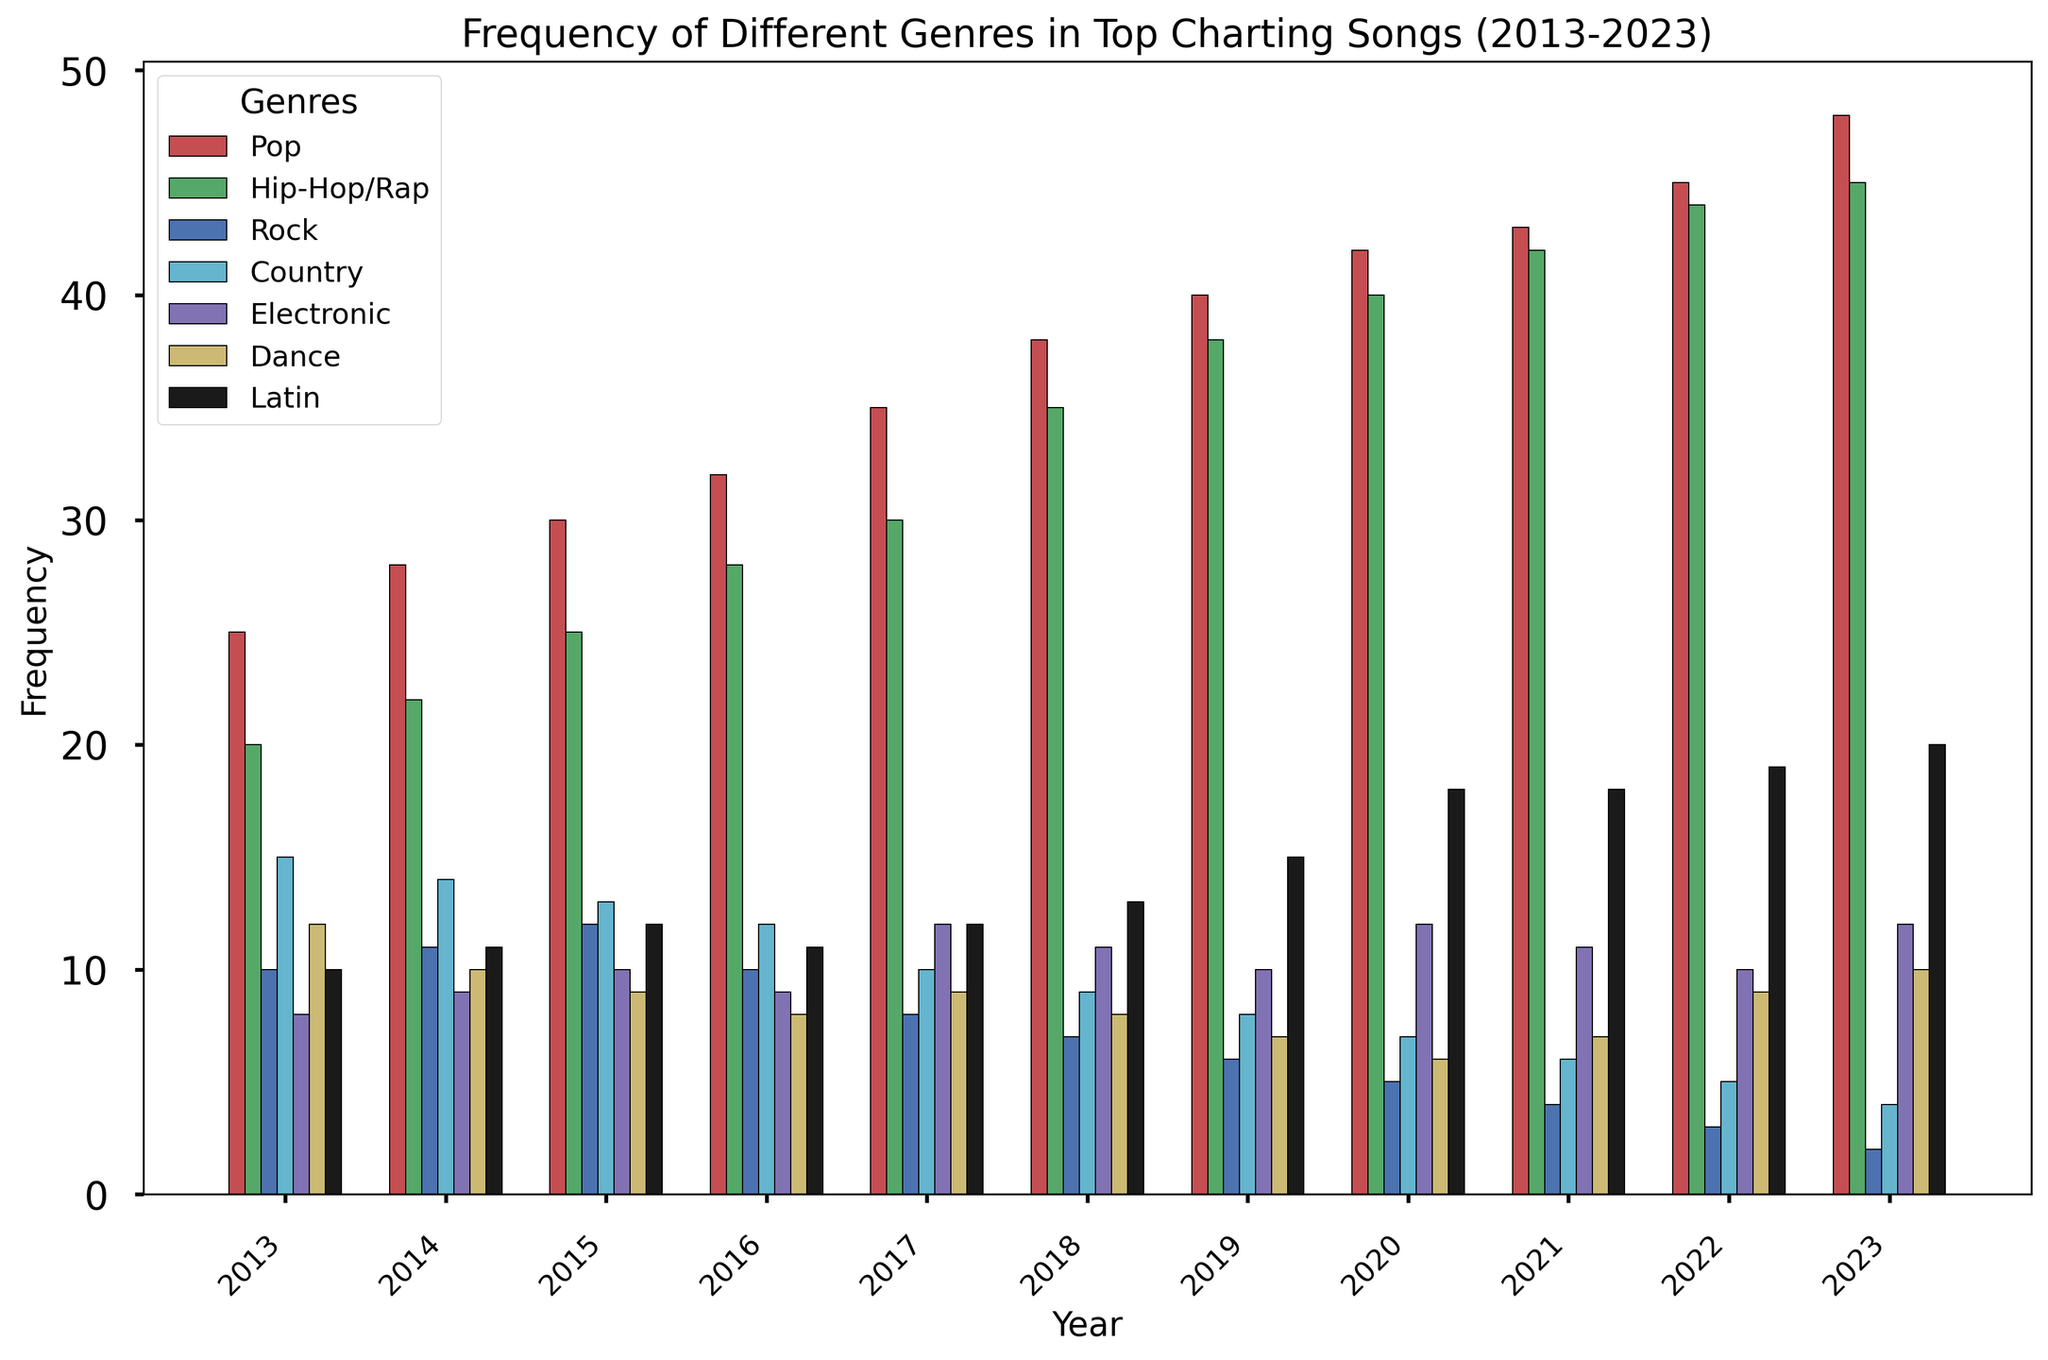What's the most frequently appearing genre in 2023? Pop has the tallest bar in 2023, indicating it is the most frequently appearing genre.
Answer: Pop Which genre has shown a consistent increase across all years? Pop and Hip-Hop/Rap both show a consistent increase from 2013 to 2023, but Pop increases in every single year without any drop.
Answer: Pop What's the sum of frequencies for Country and Dance genres in 2016? In 2016, the frequency for Country is 12, and for Dance, it is 8. Summing these gives 12 + 8 = 20.
Answer: 20 What was the trend for Rock genre from 2016 to 2023? From 2016 to 2023, the frequency of Rock songs consistently decreased, going from 10 down to 2.
Answer: Decreasing In which year did Latin music surpass Electronic music in frequency? Latin music surpassed Electronic music in 2019. In this year, Latin had a frequency of 15 while Electronic had 10.
Answer: 2019 Which genre had the smallest frequency in 2013? In 2013, the smallest frequency is for Electronic genre, with a count of 8.
Answer: Electronic Compare the frequency of Hip-Hop/Rap and Rock in 2020. In 2020, Hip-Hop/Rap has a frequency of 40, while Rock has a frequency of 5. Hip-Hop/Rap is significantly higher.
Answer: Hip-Hop/Rap Calculate the average frequency of Pop music from 2013 to 2023. The sum of frequencies for Pop from 2013 to 2023 is 25 + 28 + 30 + 32 + 35 + 38 + 40 + 42 + 43 + 45 + 48 = 406. There are 11 years, so the average is 406 / 11 ≈ 36.91.
Answer: 36.91 What visual attribute indicates that Pop music is the most dominant genre? The tallest bars across all years consistently belong to the Pop genre, indicating its dominance.
Answer: Tallest bars How much did the frequency of Latin genre increase from 2018 to 2023? In 2018, the frequency of Latin was 13, and by 2023, it increased to 20. The increase is 20 - 13 = 7.
Answer: 7 